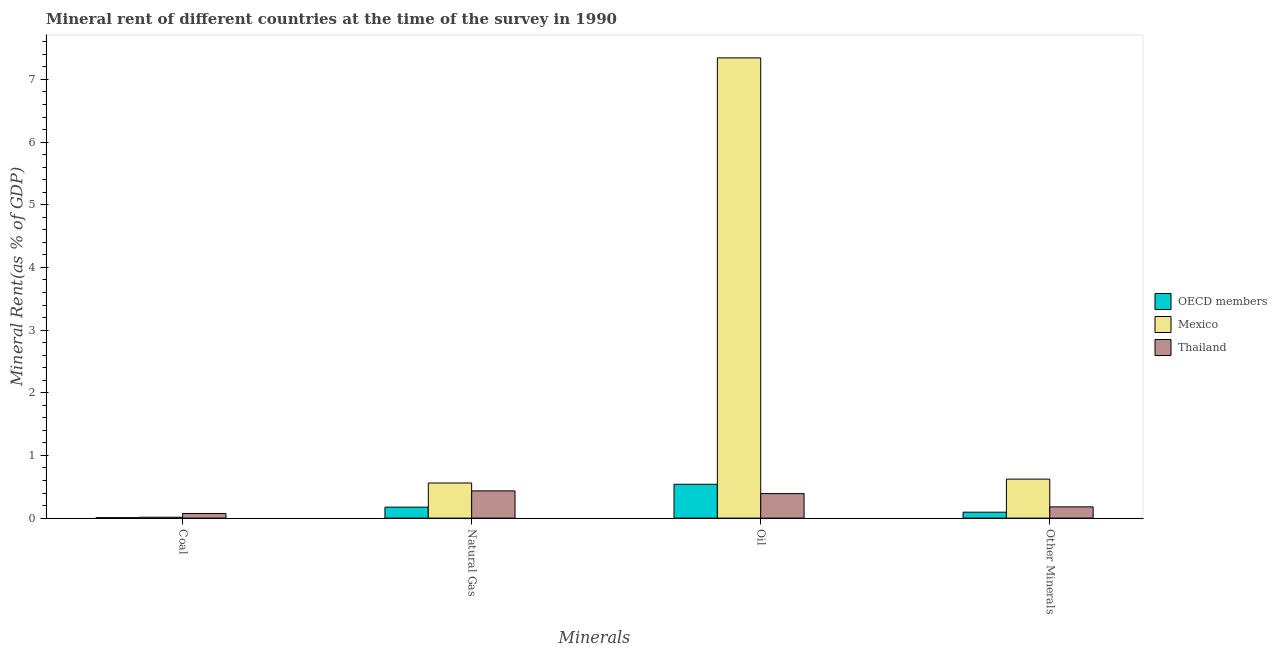How many groups of bars are there?
Make the answer very short. 4. Are the number of bars on each tick of the X-axis equal?
Make the answer very short. Yes. What is the label of the 3rd group of bars from the left?
Give a very brief answer. Oil. What is the oil rent in Thailand?
Offer a terse response. 0.39. Across all countries, what is the maximum oil rent?
Your answer should be compact. 7.34. Across all countries, what is the minimum natural gas rent?
Provide a succinct answer. 0.18. In which country was the natural gas rent maximum?
Offer a terse response. Mexico. In which country was the  rent of other minerals minimum?
Provide a succinct answer. OECD members. What is the total  rent of other minerals in the graph?
Provide a short and direct response. 0.9. What is the difference between the oil rent in Mexico and that in OECD members?
Your answer should be compact. 6.8. What is the difference between the coal rent in OECD members and the oil rent in Mexico?
Offer a terse response. -7.34. What is the average coal rent per country?
Make the answer very short. 0.03. What is the difference between the  rent of other minerals and coal rent in OECD members?
Offer a terse response. 0.09. In how many countries, is the coal rent greater than 1.6 %?
Keep it short and to the point. 0. What is the ratio of the oil rent in Mexico to that in Thailand?
Provide a succinct answer. 18.78. Is the natural gas rent in OECD members less than that in Thailand?
Offer a terse response. Yes. What is the difference between the highest and the second highest natural gas rent?
Your response must be concise. 0.13. What is the difference between the highest and the lowest oil rent?
Provide a succinct answer. 6.95. In how many countries, is the coal rent greater than the average coal rent taken over all countries?
Provide a short and direct response. 1. Is it the case that in every country, the sum of the  rent of other minerals and coal rent is greater than the sum of oil rent and natural gas rent?
Offer a terse response. No. How many bars are there?
Provide a short and direct response. 12. How many countries are there in the graph?
Give a very brief answer. 3. Does the graph contain any zero values?
Provide a short and direct response. No. Where does the legend appear in the graph?
Provide a short and direct response. Center right. What is the title of the graph?
Provide a short and direct response. Mineral rent of different countries at the time of the survey in 1990. What is the label or title of the X-axis?
Keep it short and to the point. Minerals. What is the label or title of the Y-axis?
Offer a terse response. Mineral Rent(as % of GDP). What is the Mineral Rent(as % of GDP) in OECD members in Coal?
Your answer should be very brief. 0.01. What is the Mineral Rent(as % of GDP) of Mexico in Coal?
Make the answer very short. 0.01. What is the Mineral Rent(as % of GDP) in Thailand in Coal?
Provide a succinct answer. 0.07. What is the Mineral Rent(as % of GDP) in OECD members in Natural Gas?
Offer a very short reply. 0.18. What is the Mineral Rent(as % of GDP) of Mexico in Natural Gas?
Offer a very short reply. 0.56. What is the Mineral Rent(as % of GDP) in Thailand in Natural Gas?
Give a very brief answer. 0.43. What is the Mineral Rent(as % of GDP) in OECD members in Oil?
Provide a short and direct response. 0.54. What is the Mineral Rent(as % of GDP) in Mexico in Oil?
Provide a succinct answer. 7.34. What is the Mineral Rent(as % of GDP) of Thailand in Oil?
Make the answer very short. 0.39. What is the Mineral Rent(as % of GDP) of OECD members in Other Minerals?
Give a very brief answer. 0.09. What is the Mineral Rent(as % of GDP) in Mexico in Other Minerals?
Your response must be concise. 0.62. What is the Mineral Rent(as % of GDP) of Thailand in Other Minerals?
Offer a very short reply. 0.18. Across all Minerals, what is the maximum Mineral Rent(as % of GDP) of OECD members?
Your answer should be very brief. 0.54. Across all Minerals, what is the maximum Mineral Rent(as % of GDP) of Mexico?
Offer a very short reply. 7.34. Across all Minerals, what is the maximum Mineral Rent(as % of GDP) in Thailand?
Your answer should be very brief. 0.43. Across all Minerals, what is the minimum Mineral Rent(as % of GDP) of OECD members?
Provide a succinct answer. 0.01. Across all Minerals, what is the minimum Mineral Rent(as % of GDP) in Mexico?
Offer a terse response. 0.01. Across all Minerals, what is the minimum Mineral Rent(as % of GDP) of Thailand?
Keep it short and to the point. 0.07. What is the total Mineral Rent(as % of GDP) in OECD members in the graph?
Provide a short and direct response. 0.82. What is the total Mineral Rent(as % of GDP) in Mexico in the graph?
Offer a very short reply. 8.54. What is the total Mineral Rent(as % of GDP) of Thailand in the graph?
Your answer should be very brief. 1.08. What is the difference between the Mineral Rent(as % of GDP) in OECD members in Coal and that in Natural Gas?
Provide a succinct answer. -0.17. What is the difference between the Mineral Rent(as % of GDP) in Mexico in Coal and that in Natural Gas?
Make the answer very short. -0.55. What is the difference between the Mineral Rent(as % of GDP) of Thailand in Coal and that in Natural Gas?
Ensure brevity in your answer.  -0.36. What is the difference between the Mineral Rent(as % of GDP) in OECD members in Coal and that in Oil?
Make the answer very short. -0.53. What is the difference between the Mineral Rent(as % of GDP) in Mexico in Coal and that in Oil?
Ensure brevity in your answer.  -7.33. What is the difference between the Mineral Rent(as % of GDP) in Thailand in Coal and that in Oil?
Your answer should be compact. -0.32. What is the difference between the Mineral Rent(as % of GDP) of OECD members in Coal and that in Other Minerals?
Provide a short and direct response. -0.09. What is the difference between the Mineral Rent(as % of GDP) in Mexico in Coal and that in Other Minerals?
Provide a short and direct response. -0.61. What is the difference between the Mineral Rent(as % of GDP) of Thailand in Coal and that in Other Minerals?
Offer a terse response. -0.11. What is the difference between the Mineral Rent(as % of GDP) of OECD members in Natural Gas and that in Oil?
Keep it short and to the point. -0.36. What is the difference between the Mineral Rent(as % of GDP) of Mexico in Natural Gas and that in Oil?
Your answer should be compact. -6.78. What is the difference between the Mineral Rent(as % of GDP) in Thailand in Natural Gas and that in Oil?
Your answer should be compact. 0.04. What is the difference between the Mineral Rent(as % of GDP) in OECD members in Natural Gas and that in Other Minerals?
Offer a very short reply. 0.08. What is the difference between the Mineral Rent(as % of GDP) of Mexico in Natural Gas and that in Other Minerals?
Provide a short and direct response. -0.06. What is the difference between the Mineral Rent(as % of GDP) of Thailand in Natural Gas and that in Other Minerals?
Provide a succinct answer. 0.26. What is the difference between the Mineral Rent(as % of GDP) in OECD members in Oil and that in Other Minerals?
Make the answer very short. 0.45. What is the difference between the Mineral Rent(as % of GDP) in Mexico in Oil and that in Other Minerals?
Your answer should be very brief. 6.72. What is the difference between the Mineral Rent(as % of GDP) in Thailand in Oil and that in Other Minerals?
Your response must be concise. 0.21. What is the difference between the Mineral Rent(as % of GDP) in OECD members in Coal and the Mineral Rent(as % of GDP) in Mexico in Natural Gas?
Your answer should be compact. -0.55. What is the difference between the Mineral Rent(as % of GDP) in OECD members in Coal and the Mineral Rent(as % of GDP) in Thailand in Natural Gas?
Make the answer very short. -0.43. What is the difference between the Mineral Rent(as % of GDP) of Mexico in Coal and the Mineral Rent(as % of GDP) of Thailand in Natural Gas?
Your answer should be very brief. -0.42. What is the difference between the Mineral Rent(as % of GDP) in OECD members in Coal and the Mineral Rent(as % of GDP) in Mexico in Oil?
Give a very brief answer. -7.34. What is the difference between the Mineral Rent(as % of GDP) in OECD members in Coal and the Mineral Rent(as % of GDP) in Thailand in Oil?
Your answer should be very brief. -0.38. What is the difference between the Mineral Rent(as % of GDP) in Mexico in Coal and the Mineral Rent(as % of GDP) in Thailand in Oil?
Provide a succinct answer. -0.38. What is the difference between the Mineral Rent(as % of GDP) of OECD members in Coal and the Mineral Rent(as % of GDP) of Mexico in Other Minerals?
Make the answer very short. -0.62. What is the difference between the Mineral Rent(as % of GDP) in OECD members in Coal and the Mineral Rent(as % of GDP) in Thailand in Other Minerals?
Your answer should be compact. -0.17. What is the difference between the Mineral Rent(as % of GDP) of Mexico in Coal and the Mineral Rent(as % of GDP) of Thailand in Other Minerals?
Offer a very short reply. -0.17. What is the difference between the Mineral Rent(as % of GDP) in OECD members in Natural Gas and the Mineral Rent(as % of GDP) in Mexico in Oil?
Your answer should be very brief. -7.17. What is the difference between the Mineral Rent(as % of GDP) of OECD members in Natural Gas and the Mineral Rent(as % of GDP) of Thailand in Oil?
Your response must be concise. -0.22. What is the difference between the Mineral Rent(as % of GDP) of Mexico in Natural Gas and the Mineral Rent(as % of GDP) of Thailand in Oil?
Your answer should be very brief. 0.17. What is the difference between the Mineral Rent(as % of GDP) in OECD members in Natural Gas and the Mineral Rent(as % of GDP) in Mexico in Other Minerals?
Offer a very short reply. -0.45. What is the difference between the Mineral Rent(as % of GDP) of OECD members in Natural Gas and the Mineral Rent(as % of GDP) of Thailand in Other Minerals?
Offer a very short reply. -0. What is the difference between the Mineral Rent(as % of GDP) in Mexico in Natural Gas and the Mineral Rent(as % of GDP) in Thailand in Other Minerals?
Your answer should be very brief. 0.38. What is the difference between the Mineral Rent(as % of GDP) of OECD members in Oil and the Mineral Rent(as % of GDP) of Mexico in Other Minerals?
Your answer should be compact. -0.08. What is the difference between the Mineral Rent(as % of GDP) of OECD members in Oil and the Mineral Rent(as % of GDP) of Thailand in Other Minerals?
Offer a very short reply. 0.36. What is the difference between the Mineral Rent(as % of GDP) in Mexico in Oil and the Mineral Rent(as % of GDP) in Thailand in Other Minerals?
Your response must be concise. 7.17. What is the average Mineral Rent(as % of GDP) in OECD members per Minerals?
Provide a succinct answer. 0.2. What is the average Mineral Rent(as % of GDP) in Mexico per Minerals?
Your answer should be very brief. 2.14. What is the average Mineral Rent(as % of GDP) in Thailand per Minerals?
Your response must be concise. 0.27. What is the difference between the Mineral Rent(as % of GDP) in OECD members and Mineral Rent(as % of GDP) in Mexico in Coal?
Your answer should be compact. -0.01. What is the difference between the Mineral Rent(as % of GDP) of OECD members and Mineral Rent(as % of GDP) of Thailand in Coal?
Make the answer very short. -0.07. What is the difference between the Mineral Rent(as % of GDP) in Mexico and Mineral Rent(as % of GDP) in Thailand in Coal?
Your answer should be compact. -0.06. What is the difference between the Mineral Rent(as % of GDP) in OECD members and Mineral Rent(as % of GDP) in Mexico in Natural Gas?
Offer a very short reply. -0.39. What is the difference between the Mineral Rent(as % of GDP) in OECD members and Mineral Rent(as % of GDP) in Thailand in Natural Gas?
Provide a succinct answer. -0.26. What is the difference between the Mineral Rent(as % of GDP) in Mexico and Mineral Rent(as % of GDP) in Thailand in Natural Gas?
Keep it short and to the point. 0.13. What is the difference between the Mineral Rent(as % of GDP) of OECD members and Mineral Rent(as % of GDP) of Mexico in Oil?
Keep it short and to the point. -6.8. What is the difference between the Mineral Rent(as % of GDP) of OECD members and Mineral Rent(as % of GDP) of Thailand in Oil?
Keep it short and to the point. 0.15. What is the difference between the Mineral Rent(as % of GDP) of Mexico and Mineral Rent(as % of GDP) of Thailand in Oil?
Provide a short and direct response. 6.95. What is the difference between the Mineral Rent(as % of GDP) of OECD members and Mineral Rent(as % of GDP) of Mexico in Other Minerals?
Your response must be concise. -0.53. What is the difference between the Mineral Rent(as % of GDP) in OECD members and Mineral Rent(as % of GDP) in Thailand in Other Minerals?
Ensure brevity in your answer.  -0.08. What is the difference between the Mineral Rent(as % of GDP) in Mexico and Mineral Rent(as % of GDP) in Thailand in Other Minerals?
Provide a succinct answer. 0.44. What is the ratio of the Mineral Rent(as % of GDP) of OECD members in Coal to that in Natural Gas?
Give a very brief answer. 0.04. What is the ratio of the Mineral Rent(as % of GDP) of Mexico in Coal to that in Natural Gas?
Ensure brevity in your answer.  0.03. What is the ratio of the Mineral Rent(as % of GDP) of Thailand in Coal to that in Natural Gas?
Ensure brevity in your answer.  0.17. What is the ratio of the Mineral Rent(as % of GDP) of OECD members in Coal to that in Oil?
Provide a succinct answer. 0.01. What is the ratio of the Mineral Rent(as % of GDP) in Mexico in Coal to that in Oil?
Provide a succinct answer. 0. What is the ratio of the Mineral Rent(as % of GDP) of Thailand in Coal to that in Oil?
Provide a succinct answer. 0.19. What is the ratio of the Mineral Rent(as % of GDP) in OECD members in Coal to that in Other Minerals?
Provide a succinct answer. 0.07. What is the ratio of the Mineral Rent(as % of GDP) in Mexico in Coal to that in Other Minerals?
Your response must be concise. 0.02. What is the ratio of the Mineral Rent(as % of GDP) in Thailand in Coal to that in Other Minerals?
Your answer should be compact. 0.41. What is the ratio of the Mineral Rent(as % of GDP) in OECD members in Natural Gas to that in Oil?
Your response must be concise. 0.32. What is the ratio of the Mineral Rent(as % of GDP) in Mexico in Natural Gas to that in Oil?
Offer a terse response. 0.08. What is the ratio of the Mineral Rent(as % of GDP) in Thailand in Natural Gas to that in Oil?
Give a very brief answer. 1.11. What is the ratio of the Mineral Rent(as % of GDP) of OECD members in Natural Gas to that in Other Minerals?
Your response must be concise. 1.85. What is the ratio of the Mineral Rent(as % of GDP) in Mexico in Natural Gas to that in Other Minerals?
Make the answer very short. 0.9. What is the ratio of the Mineral Rent(as % of GDP) of Thailand in Natural Gas to that in Other Minerals?
Your answer should be compact. 2.43. What is the ratio of the Mineral Rent(as % of GDP) in OECD members in Oil to that in Other Minerals?
Keep it short and to the point. 5.69. What is the ratio of the Mineral Rent(as % of GDP) of Mexico in Oil to that in Other Minerals?
Give a very brief answer. 11.8. What is the ratio of the Mineral Rent(as % of GDP) in Thailand in Oil to that in Other Minerals?
Make the answer very short. 2.18. What is the difference between the highest and the second highest Mineral Rent(as % of GDP) in OECD members?
Your response must be concise. 0.36. What is the difference between the highest and the second highest Mineral Rent(as % of GDP) of Mexico?
Ensure brevity in your answer.  6.72. What is the difference between the highest and the second highest Mineral Rent(as % of GDP) of Thailand?
Ensure brevity in your answer.  0.04. What is the difference between the highest and the lowest Mineral Rent(as % of GDP) in OECD members?
Your answer should be very brief. 0.53. What is the difference between the highest and the lowest Mineral Rent(as % of GDP) of Mexico?
Offer a terse response. 7.33. What is the difference between the highest and the lowest Mineral Rent(as % of GDP) in Thailand?
Keep it short and to the point. 0.36. 